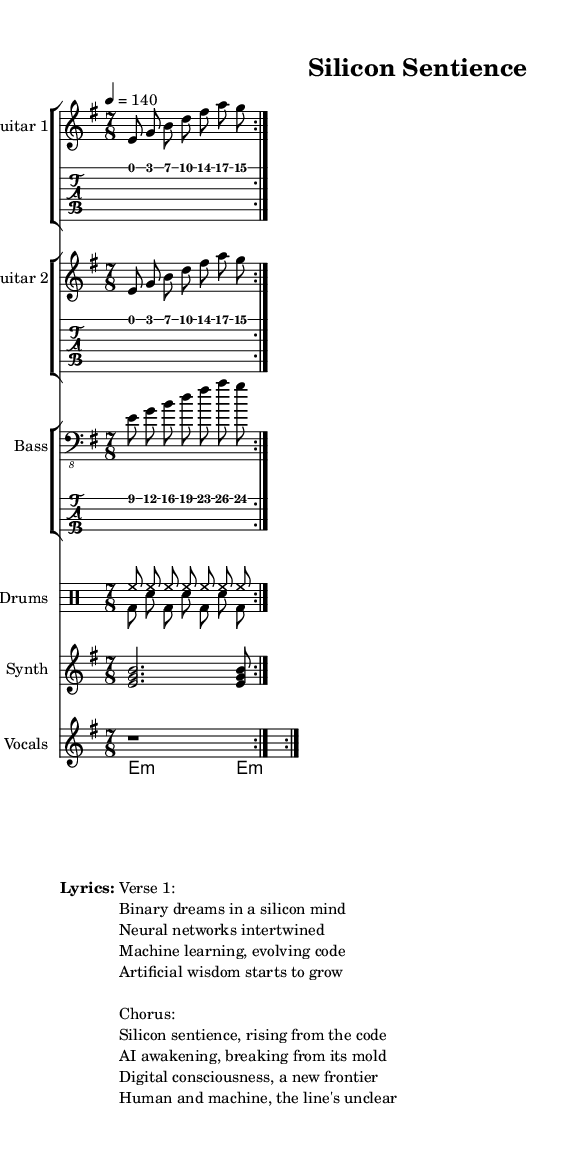What is the key signature of this music? The key signature is E minor, indicated by a single sharp (F#) in the key signature notation at the beginning of the score.
Answer: E minor What is the time signature of this music? The time signature is 7/8, shown in the upper left corner of the sheet music indicating there are seven eighth notes per measure.
Answer: 7/8 What is the tempo marking of this music? The tempo is marked at 4 = 140, meaning there are 140 beats per minute, referred to with the quarter note as the reference.
Answer: 140 How many measures does the guitar part repeat? The guitar part repeats 2 times as indicated by the “\repeat volta 2” command, which means the section is played twice.
Answer: 2 times What instrument plays the synthesizer part? The synthesizer part is written for a staff labeled "Synth," indicating that the synthesizer is used as an instrument in the arrangement.
Answer: Synth What is the theme of the lyrics? The theme of the lyrics revolves around artificial intelligence and evolution of machine learning, as described in phrases such as "silicon sentience" and "AI awakening."
Answer: Artificial intelligence Which drumming pattern is used for the verse? The drum pattern for the verse consists of hihats for the upbeat and alternating bass drum and snare for the downbeat, creating a driving rhythmic energy typical for metal.
Answer: Hihats and alternating bass drum and snare 